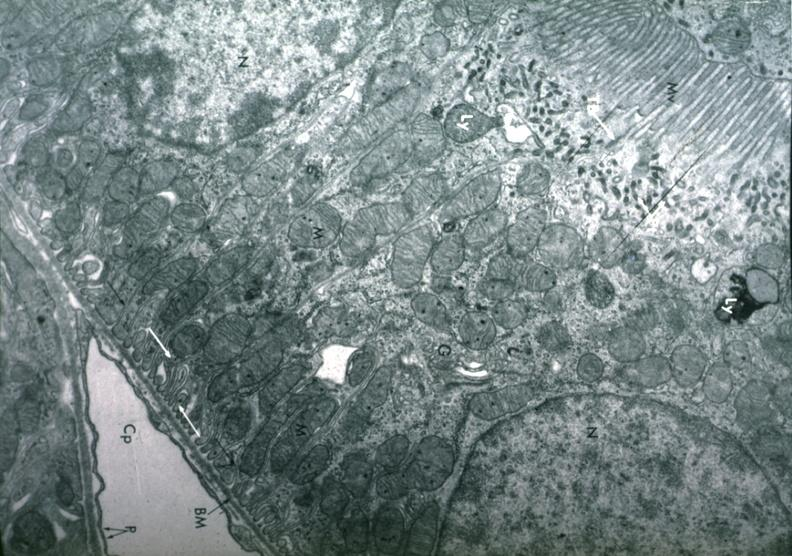what is present?
Answer the question using a single word or phrase. Kidney 